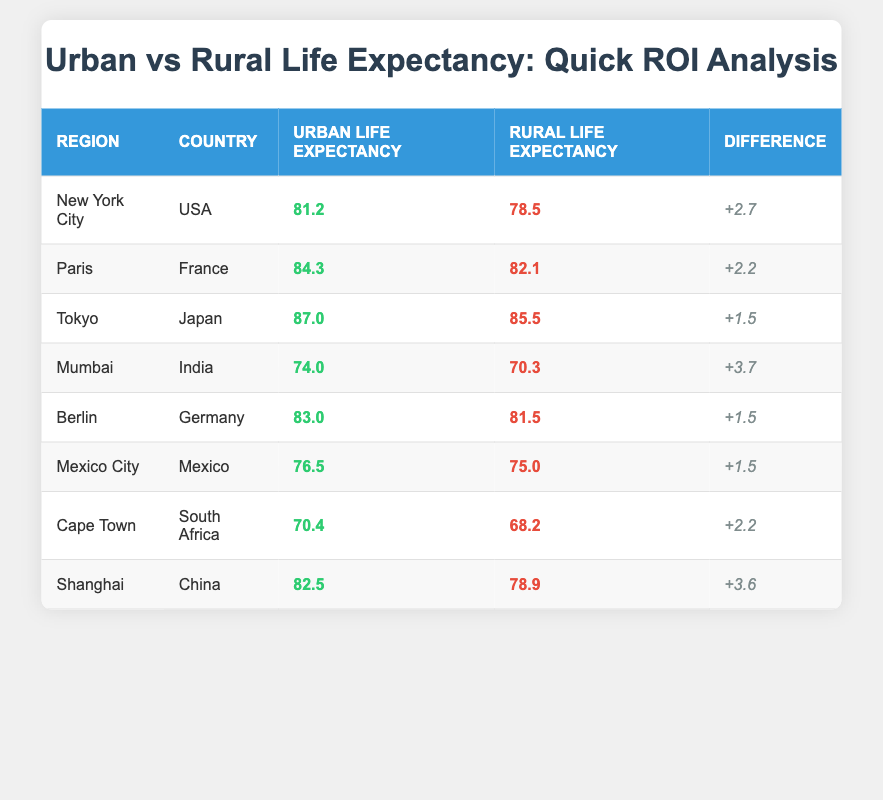What is the urban life expectancy in Tokyo? The urban life expectancy value for Tokyo is directly available in the table, listed under the "Urban Life Expectancy" column for Tokyo.
Answer: 87.0 Which region has the highest rural life expectancy? By comparing the "Rural Life Expectancy" values in the table, we see that Tokyo has the highest value of 85.5.
Answer: Tokyo How much higher is rural life expectancy in Mumbai compared to Cape Town? The rural life expectancy in Mumbai is 70.3, and in Cape Town, it is 68.2. The difference is calculated by subtracting Cape Town's value from Mumbai's: 70.3 - 68.2 = 2.1.
Answer: 2.1 Is urban life expectancy in Paris greater than urban life expectancy in Berlin? The urban life expectancy for Paris is 84.3, and for Berlin, it is 83.0. Since 84.3 is greater than 83.0, the statement is true.
Answer: Yes What is the average difference between urban and rural life expectancy across all regions in the table? To find the average difference, first calculate the differences for each region: New York City (2.7), Paris (2.2), Tokyo (1.5), Mumbai (3.7), Berlin (1.5), Mexico City (1.5), Cape Town (2.2), Shanghai (3.6). The sum of these differences is 19.0 and there are 8 regions, so the average difference is 19.0 / 8 = 2.375.
Answer: 2.375 Which country has the largest difference between urban and rural life expectancy? By examining the differences listed in the table, Mumbai has the largest difference of 3.7 between urban (74.0) and rural (70.3) life expectancy.
Answer: India What is the total urban life expectancy for all regions in the table? To calculate the total urban life expectancy, sum the urban values for each region: 81.2 (New York City) + 84.3 (Paris) + 87.0 (Tokyo) + 74.0 (Mumbai) + 83.0 (Berlin) + 76.5 (Mexico City) + 70.4 (Cape Town) + 82.5 (Shanghai) = 539.0.
Answer: 539.0 Is the urban life expectancy in Shanghai greater than that in Cape Town? The urban life expectancy for Shanghai is 82.5, while for Cape Town it is 70.4. Since 82.5 is indeed greater than 70.4, the statement is true.
Answer: Yes 